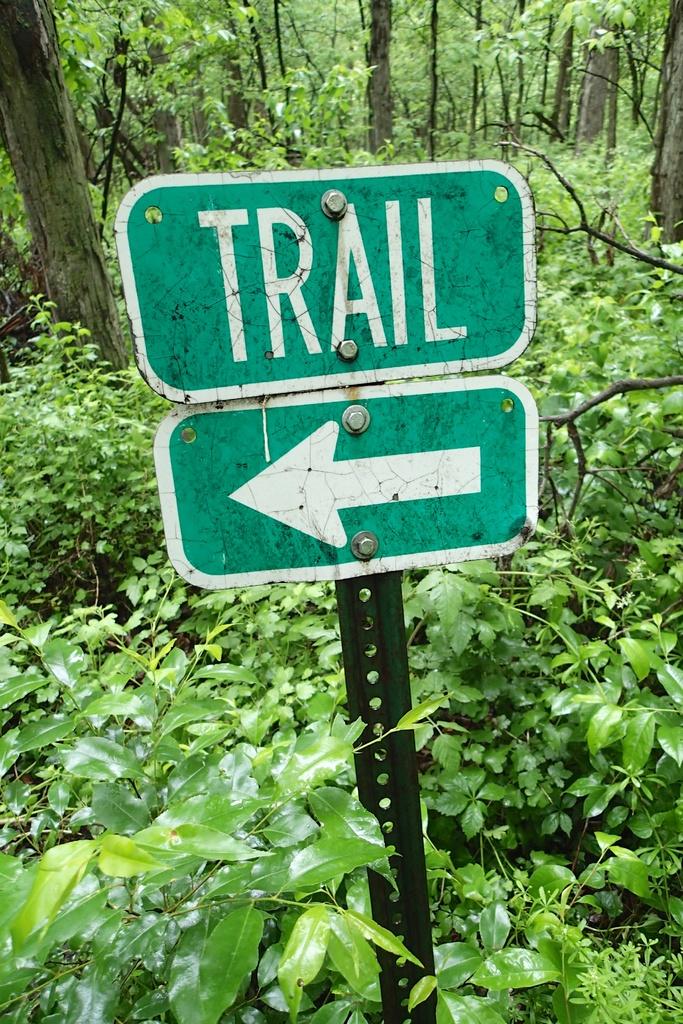What does the arrow lead you to?
Offer a very short reply. Trail. What is the first letter of the word in the sign?
Your answer should be very brief. T. 